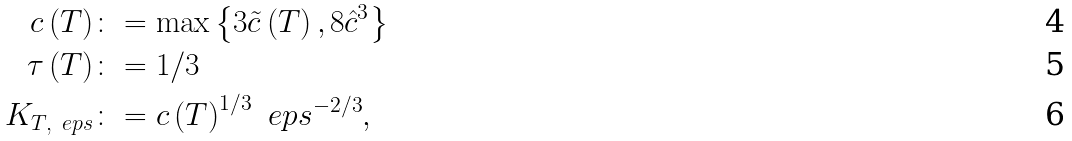Convert formula to latex. <formula><loc_0><loc_0><loc_500><loc_500>c \left ( T \right ) & \colon = \max \left \{ 3 \tilde { c } \left ( T \right ) , 8 \hat { c } ^ { 3 } \right \} \\ \tau \left ( T \right ) & \colon = 1 / 3 \\ K _ { T , \ e p s } & \colon = c \left ( T \right ) ^ { 1 / 3 } \ e p s ^ { - 2 / 3 } ,</formula> 